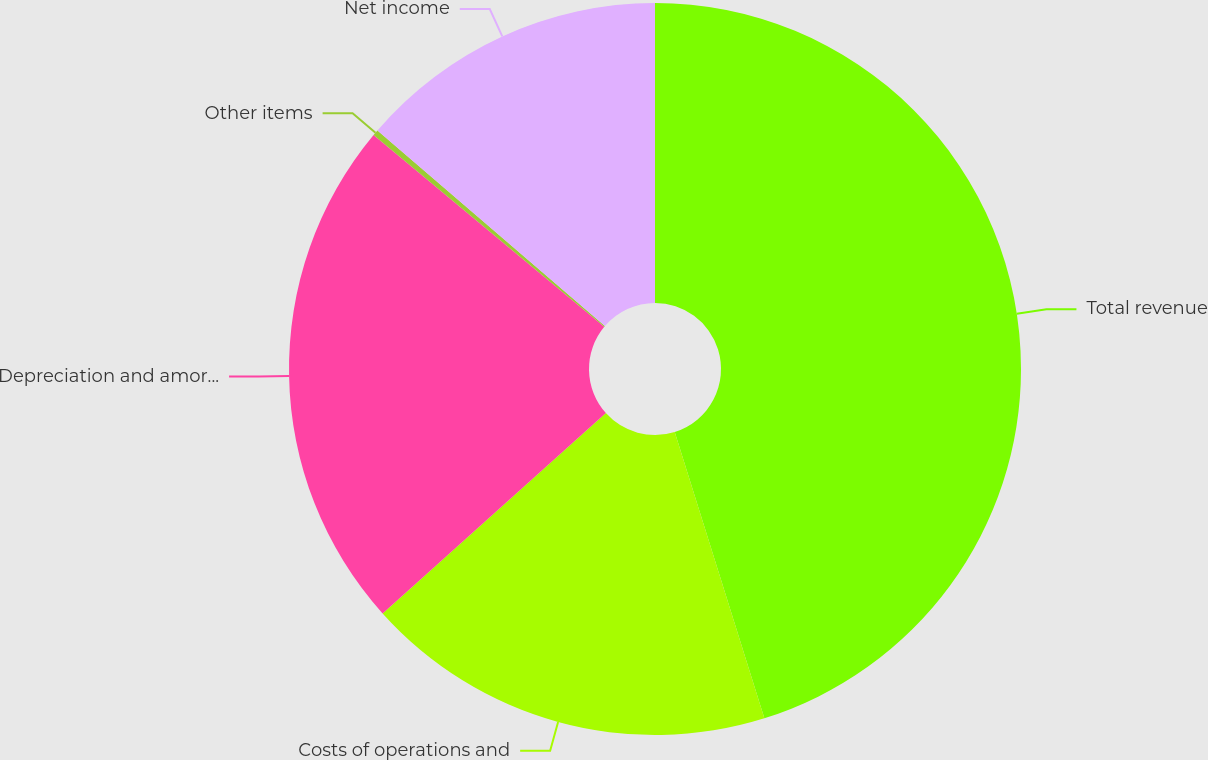Convert chart to OTSL. <chart><loc_0><loc_0><loc_500><loc_500><pie_chart><fcel>Total revenue<fcel>Costs of operations and<fcel>Depreciation and amortization<fcel>Other items<fcel>Net income<nl><fcel>45.17%<fcel>18.19%<fcel>22.68%<fcel>0.26%<fcel>13.7%<nl></chart> 